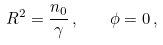<formula> <loc_0><loc_0><loc_500><loc_500>R ^ { 2 } = \frac { n _ { 0 } } { \gamma } \, , \quad \phi = 0 \, ,</formula> 